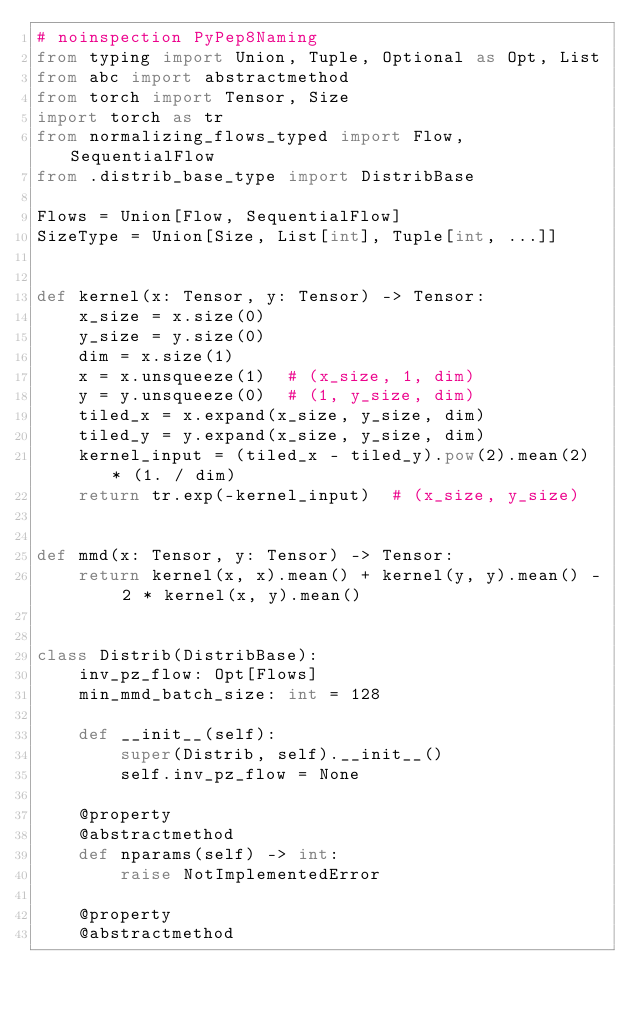<code> <loc_0><loc_0><loc_500><loc_500><_Python_># noinspection PyPep8Naming
from typing import Union, Tuple, Optional as Opt, List
from abc import abstractmethod
from torch import Tensor, Size
import torch as tr
from normalizing_flows_typed import Flow, SequentialFlow
from .distrib_base_type import DistribBase

Flows = Union[Flow, SequentialFlow]
SizeType = Union[Size, List[int], Tuple[int, ...]]


def kernel(x: Tensor, y: Tensor) -> Tensor:
    x_size = x.size(0)
    y_size = y.size(0)
    dim = x.size(1)
    x = x.unsqueeze(1)  # (x_size, 1, dim)
    y = y.unsqueeze(0)  # (1, y_size, dim)
    tiled_x = x.expand(x_size, y_size, dim)
    tiled_y = y.expand(x_size, y_size, dim)
    kernel_input = (tiled_x - tiled_y).pow(2).mean(2) * (1. / dim)
    return tr.exp(-kernel_input)  # (x_size, y_size)


def mmd(x: Tensor, y: Tensor) -> Tensor:
    return kernel(x, x).mean() + kernel(y, y).mean() - 2 * kernel(x, y).mean()


class Distrib(DistribBase):
    inv_pz_flow: Opt[Flows]
    min_mmd_batch_size: int = 128

    def __init__(self):
        super(Distrib, self).__init__()
        self.inv_pz_flow = None

    @property
    @abstractmethod
    def nparams(self) -> int:
        raise NotImplementedError

    @property
    @abstractmethod</code> 